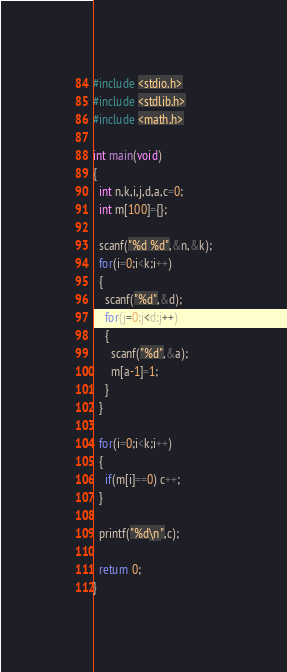<code> <loc_0><loc_0><loc_500><loc_500><_C_>#include <stdio.h>
#include <stdlib.h>
#include <math.h>

int main(void)
{
  int n,k,i,j,d,a,c=0;
  int m[100]={};

  scanf("%d %d",&n,&k);
  for(i=0;i<k;i++)
  {
    scanf("%d",&d);
    for(j=0;j<d;j++)
    {
      scanf("%d",&a);
      m[a-1]=1;
    }
  }

  for(i=0;i<k;i++)
  {
    if(m[i]==0) c++;
  }

  printf("%d\n",c);

  return 0;
}</code> 